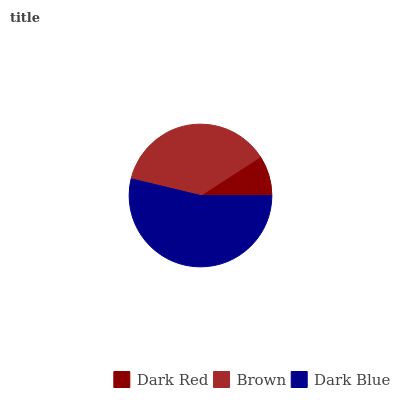Is Dark Red the minimum?
Answer yes or no. Yes. Is Dark Blue the maximum?
Answer yes or no. Yes. Is Brown the minimum?
Answer yes or no. No. Is Brown the maximum?
Answer yes or no. No. Is Brown greater than Dark Red?
Answer yes or no. Yes. Is Dark Red less than Brown?
Answer yes or no. Yes. Is Dark Red greater than Brown?
Answer yes or no. No. Is Brown less than Dark Red?
Answer yes or no. No. Is Brown the high median?
Answer yes or no. Yes. Is Brown the low median?
Answer yes or no. Yes. Is Dark Blue the high median?
Answer yes or no. No. Is Dark Red the low median?
Answer yes or no. No. 